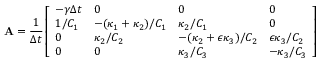Convert formula to latex. <formula><loc_0><loc_0><loc_500><loc_500>A = \frac { 1 } { \Delta t } \left [ \begin{array} { l l l l } { - \gamma \Delta t } & { 0 } & { 0 } & { 0 } \\ { 1 / C _ { 1 } } & { - ( \kappa _ { 1 } + \kappa _ { 2 } ) / C _ { 1 } } & { \kappa _ { 2 } / C _ { 1 } } & { 0 } \\ { 0 } & { \kappa _ { 2 } / C _ { 2 } } & { - ( \kappa _ { 2 } + \epsilon \kappa _ { 3 } ) / C _ { 2 } } & { \epsilon \kappa _ { 3 } / C _ { 2 } } \\ { 0 } & { 0 } & { \kappa _ { 3 } / C _ { 3 } } & { - \kappa _ { 3 } / C _ { 3 } } \end{array} \right ]</formula> 